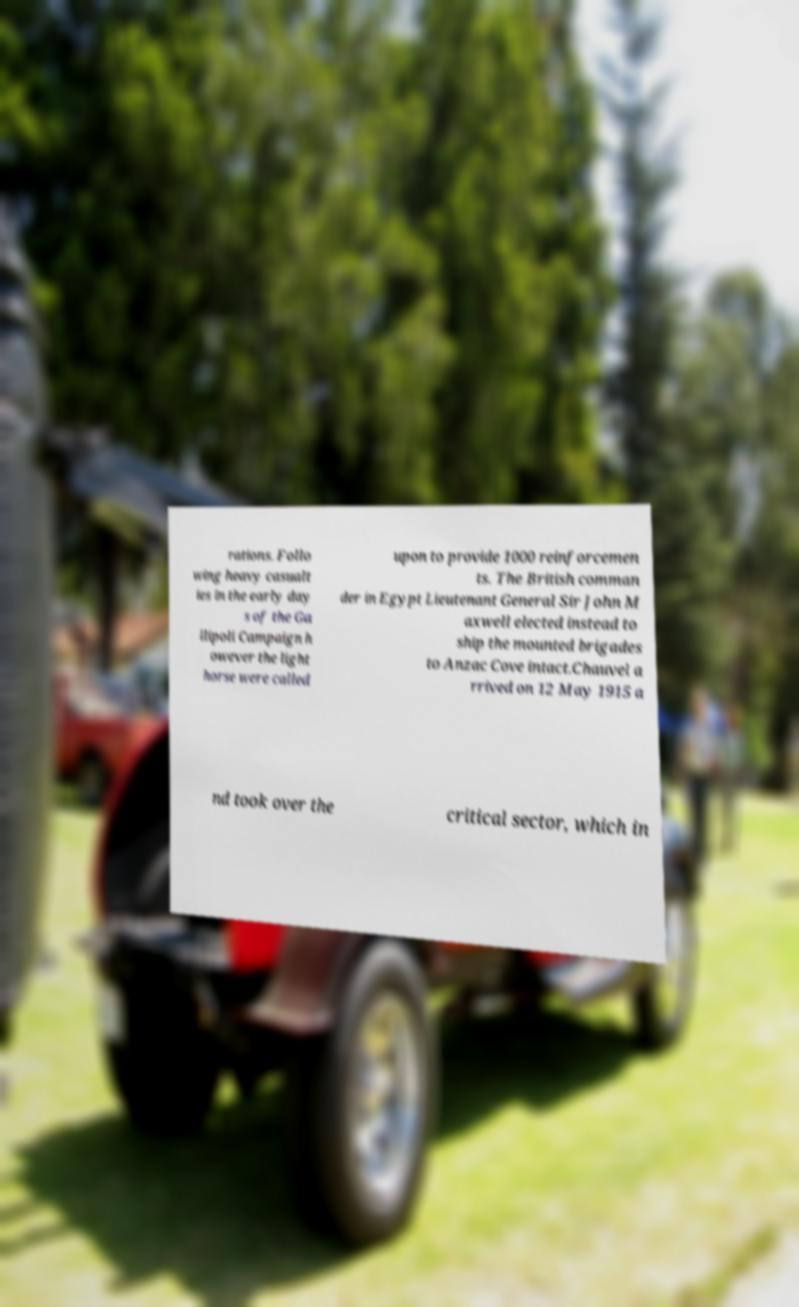Please identify and transcribe the text found in this image. rations. Follo wing heavy casualt ies in the early day s of the Ga llipoli Campaign h owever the light horse were called upon to provide 1000 reinforcemen ts. The British comman der in Egypt Lieutenant General Sir John M axwell elected instead to ship the mounted brigades to Anzac Cove intact.Chauvel a rrived on 12 May 1915 a nd took over the critical sector, which in 